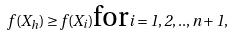<formula> <loc_0><loc_0><loc_500><loc_500>f ( X _ { h } ) \geq f ( X _ { i } ) \text {for} i = 1 , 2 , . . , n + 1 ,</formula> 